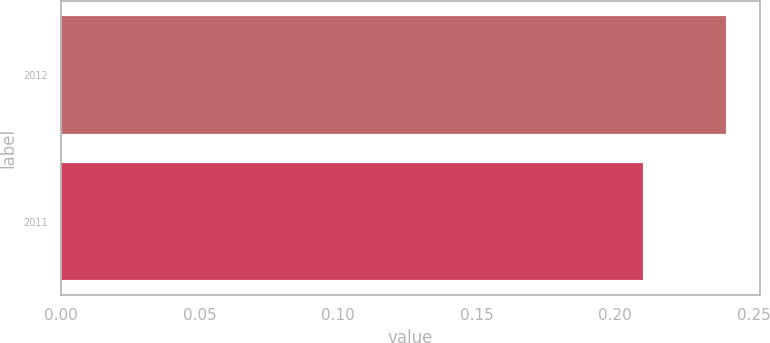<chart> <loc_0><loc_0><loc_500><loc_500><bar_chart><fcel>2012<fcel>2011<nl><fcel>0.24<fcel>0.21<nl></chart> 